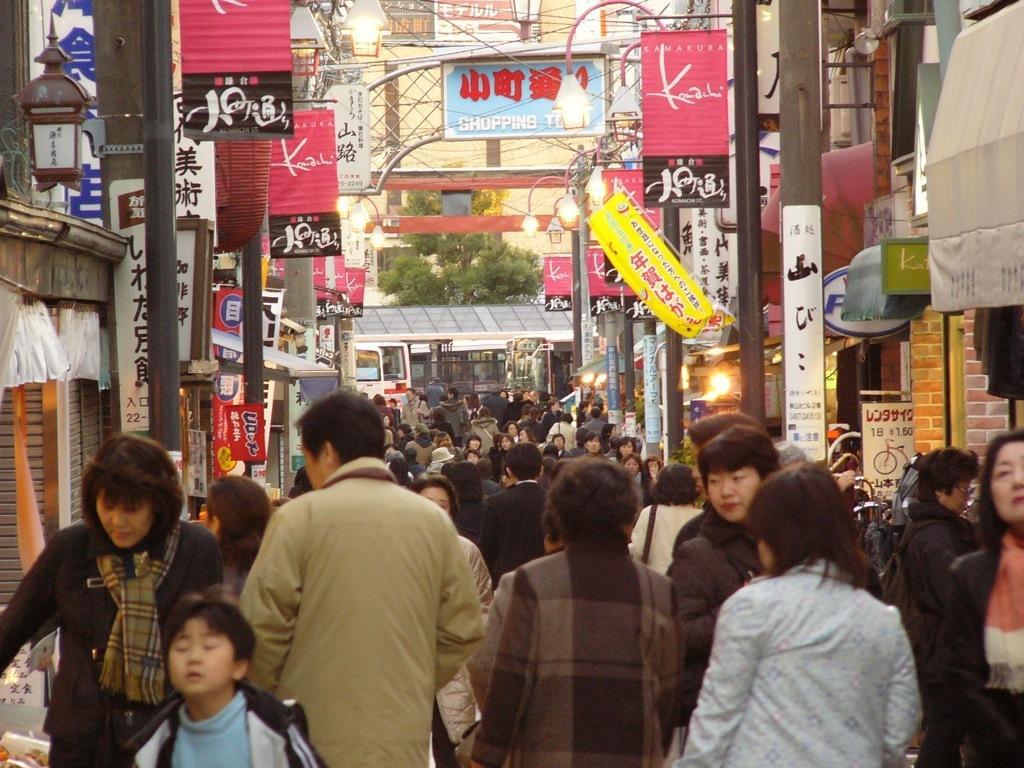Describe this image in one or two sentences. This image consists of many people walking on the road. On the left and right, there are buildings along with poles and boards. In the background, we can see the trees. 